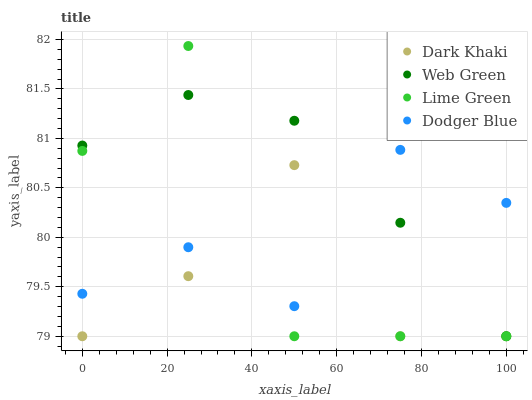Does Dark Khaki have the minimum area under the curve?
Answer yes or no. Yes. Does Web Green have the maximum area under the curve?
Answer yes or no. Yes. Does Dodger Blue have the minimum area under the curve?
Answer yes or no. No. Does Dodger Blue have the maximum area under the curve?
Answer yes or no. No. Is Web Green the smoothest?
Answer yes or no. Yes. Is Lime Green the roughest?
Answer yes or no. Yes. Is Dodger Blue the smoothest?
Answer yes or no. No. Is Dodger Blue the roughest?
Answer yes or no. No. Does Dark Khaki have the lowest value?
Answer yes or no. Yes. Does Dodger Blue have the lowest value?
Answer yes or no. No. Does Lime Green have the highest value?
Answer yes or no. Yes. Does Dodger Blue have the highest value?
Answer yes or no. No. Does Lime Green intersect Dark Khaki?
Answer yes or no. Yes. Is Lime Green less than Dark Khaki?
Answer yes or no. No. Is Lime Green greater than Dark Khaki?
Answer yes or no. No. 